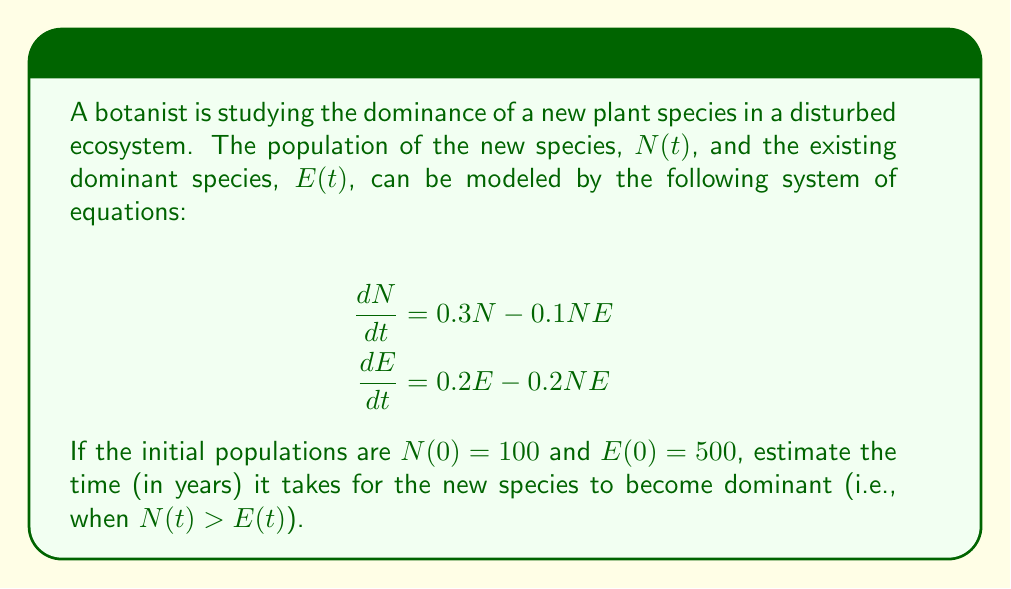Teach me how to tackle this problem. To solve this problem, we need to use numerical methods to approximate the solution of the system of differential equations. We'll use the Euler method with a small time step to estimate the populations over time.

1. Set up the Euler method:
   Let $h = 0.1$ be our time step (in years).
   For each step, we'll update $N$ and $E$ using:
   $$N_{i+1} = N_i + h(0.3N_i - 0.1N_iE_i)$$
   $$E_{i+1} = E_i + h(0.2E_i - 0.2N_iE_i)$$

2. Initialize variables:
   $t = 0$, $N = 100$, $E = 500$

3. Iterate until $N > E$:
   $t = 0.1$: $N \approx 102.9$, $E \approx 505.0$
   $t = 0.2$: $N \approx 105.9$, $E \approx 509.9$
   ...
   $t = 10.0$: $N \approx 286.7$, $E \approx 290.1$
   $t = 10.1$: $N \approx 289.6$, $E \approx 289.3$

4. The new species becomes dominant when $t \approx 10.1$ years.

Note: This is an approximation, and the actual time may vary slightly depending on the numerical method and step size used.
Answer: Approximately 10.1 years 